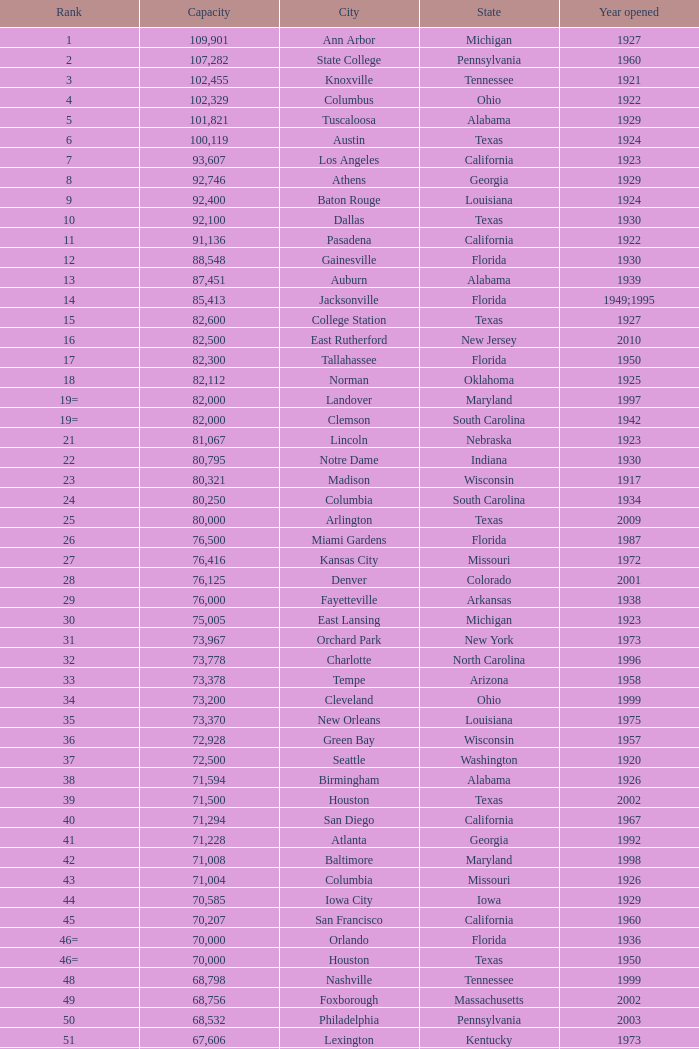In which year did north carolina open a venue with a capacity of less than 21,500? 1926.0. 